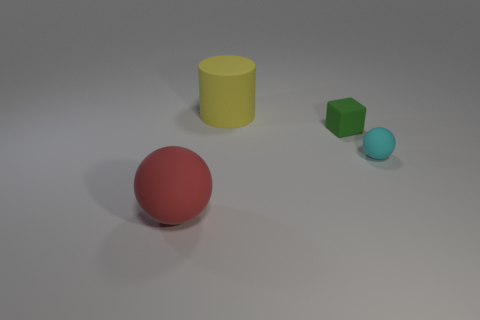What color is the large object that is made of the same material as the red sphere?
Provide a succinct answer. Yellow. What number of objects are balls that are right of the big red rubber ball or things that are to the left of the tiny green matte object?
Provide a short and direct response. 3. Is the size of the matte ball that is left of the tiny block the same as the ball that is on the right side of the big red thing?
Keep it short and to the point. No. There is another rubber object that is the same shape as the large red rubber thing; what color is it?
Give a very brief answer. Cyan. Is there any other thing that is the same shape as the red object?
Keep it short and to the point. Yes. Is the number of small green objects that are in front of the red matte object greater than the number of tiny cyan matte balls that are left of the tiny cube?
Make the answer very short. No. There is a matte ball that is right of the matte object that is on the left side of the big object that is on the right side of the red sphere; what is its size?
Your answer should be compact. Small. Does the cyan thing have the same shape as the big red rubber thing?
Provide a short and direct response. Yes. How many other things are made of the same material as the tiny green object?
Provide a succinct answer. 3. What number of cyan things have the same shape as the red object?
Give a very brief answer. 1. 